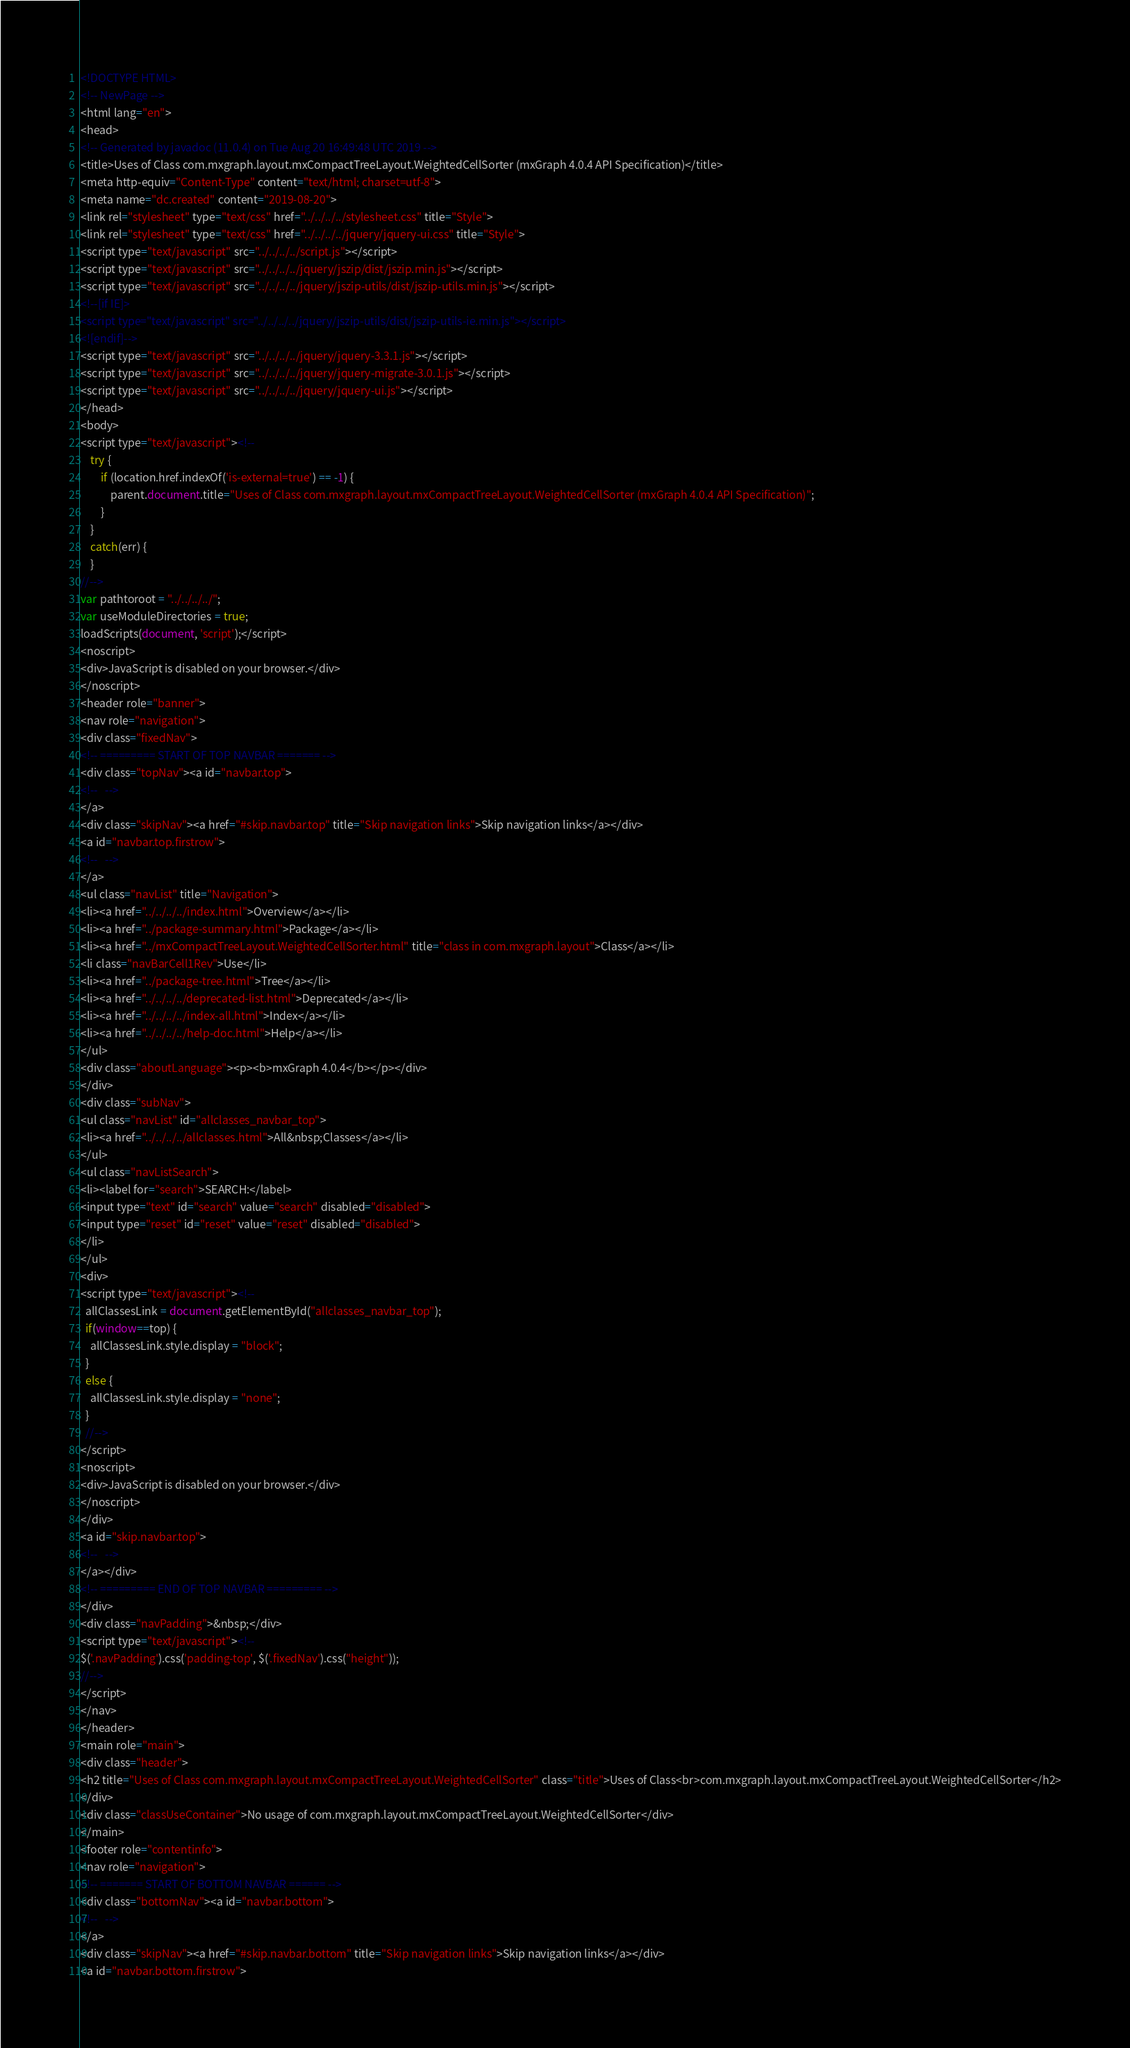Convert code to text. <code><loc_0><loc_0><loc_500><loc_500><_HTML_><!DOCTYPE HTML>
<!-- NewPage -->
<html lang="en">
<head>
<!-- Generated by javadoc (11.0.4) on Tue Aug 20 16:49:48 UTC 2019 -->
<title>Uses of Class com.mxgraph.layout.mxCompactTreeLayout.WeightedCellSorter (mxGraph 4.0.4 API Specification)</title>
<meta http-equiv="Content-Type" content="text/html; charset=utf-8">
<meta name="dc.created" content="2019-08-20">
<link rel="stylesheet" type="text/css" href="../../../../stylesheet.css" title="Style">
<link rel="stylesheet" type="text/css" href="../../../../jquery/jquery-ui.css" title="Style">
<script type="text/javascript" src="../../../../script.js"></script>
<script type="text/javascript" src="../../../../jquery/jszip/dist/jszip.min.js"></script>
<script type="text/javascript" src="../../../../jquery/jszip-utils/dist/jszip-utils.min.js"></script>
<!--[if IE]>
<script type="text/javascript" src="../../../../jquery/jszip-utils/dist/jszip-utils-ie.min.js"></script>
<![endif]-->
<script type="text/javascript" src="../../../../jquery/jquery-3.3.1.js"></script>
<script type="text/javascript" src="../../../../jquery/jquery-migrate-3.0.1.js"></script>
<script type="text/javascript" src="../../../../jquery/jquery-ui.js"></script>
</head>
<body>
<script type="text/javascript"><!--
    try {
        if (location.href.indexOf('is-external=true') == -1) {
            parent.document.title="Uses of Class com.mxgraph.layout.mxCompactTreeLayout.WeightedCellSorter (mxGraph 4.0.4 API Specification)";
        }
    }
    catch(err) {
    }
//-->
var pathtoroot = "../../../../";
var useModuleDirectories = true;
loadScripts(document, 'script');</script>
<noscript>
<div>JavaScript is disabled on your browser.</div>
</noscript>
<header role="banner">
<nav role="navigation">
<div class="fixedNav">
<!-- ========= START OF TOP NAVBAR ======= -->
<div class="topNav"><a id="navbar.top">
<!--   -->
</a>
<div class="skipNav"><a href="#skip.navbar.top" title="Skip navigation links">Skip navigation links</a></div>
<a id="navbar.top.firstrow">
<!--   -->
</a>
<ul class="navList" title="Navigation">
<li><a href="../../../../index.html">Overview</a></li>
<li><a href="../package-summary.html">Package</a></li>
<li><a href="../mxCompactTreeLayout.WeightedCellSorter.html" title="class in com.mxgraph.layout">Class</a></li>
<li class="navBarCell1Rev">Use</li>
<li><a href="../package-tree.html">Tree</a></li>
<li><a href="../../../../deprecated-list.html">Deprecated</a></li>
<li><a href="../../../../index-all.html">Index</a></li>
<li><a href="../../../../help-doc.html">Help</a></li>
</ul>
<div class="aboutLanguage"><p><b>mxGraph 4.0.4</b></p></div>
</div>
<div class="subNav">
<ul class="navList" id="allclasses_navbar_top">
<li><a href="../../../../allclasses.html">All&nbsp;Classes</a></li>
</ul>
<ul class="navListSearch">
<li><label for="search">SEARCH:</label>
<input type="text" id="search" value="search" disabled="disabled">
<input type="reset" id="reset" value="reset" disabled="disabled">
</li>
</ul>
<div>
<script type="text/javascript"><!--
  allClassesLink = document.getElementById("allclasses_navbar_top");
  if(window==top) {
    allClassesLink.style.display = "block";
  }
  else {
    allClassesLink.style.display = "none";
  }
  //-->
</script>
<noscript>
<div>JavaScript is disabled on your browser.</div>
</noscript>
</div>
<a id="skip.navbar.top">
<!--   -->
</a></div>
<!-- ========= END OF TOP NAVBAR ========= -->
</div>
<div class="navPadding">&nbsp;</div>
<script type="text/javascript"><!--
$('.navPadding').css('padding-top', $('.fixedNav').css("height"));
//-->
</script>
</nav>
</header>
<main role="main">
<div class="header">
<h2 title="Uses of Class com.mxgraph.layout.mxCompactTreeLayout.WeightedCellSorter" class="title">Uses of Class<br>com.mxgraph.layout.mxCompactTreeLayout.WeightedCellSorter</h2>
</div>
<div class="classUseContainer">No usage of com.mxgraph.layout.mxCompactTreeLayout.WeightedCellSorter</div>
</main>
<footer role="contentinfo">
<nav role="navigation">
<!-- ======= START OF BOTTOM NAVBAR ====== -->
<div class="bottomNav"><a id="navbar.bottom">
<!--   -->
</a>
<div class="skipNav"><a href="#skip.navbar.bottom" title="Skip navigation links">Skip navigation links</a></div>
<a id="navbar.bottom.firstrow"></code> 